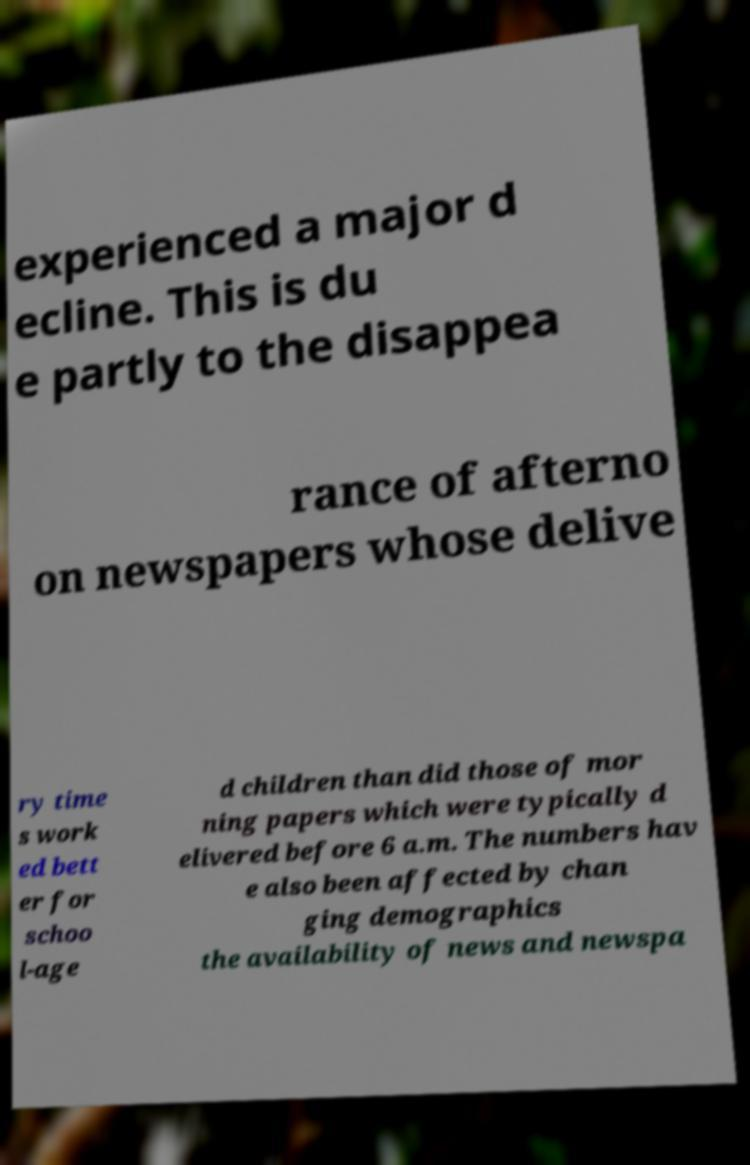Please read and relay the text visible in this image. What does it say? experienced a major d ecline. This is du e partly to the disappea rance of afterno on newspapers whose delive ry time s work ed bett er for schoo l-age d children than did those of mor ning papers which were typically d elivered before 6 a.m. The numbers hav e also been affected by chan ging demographics the availability of news and newspa 